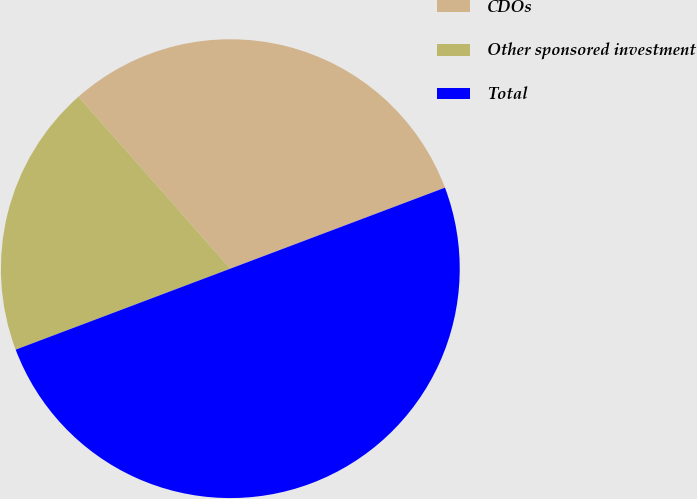Convert chart. <chart><loc_0><loc_0><loc_500><loc_500><pie_chart><fcel>CDOs<fcel>Other sponsored investment<fcel>Total<nl><fcel>30.77%<fcel>19.23%<fcel>50.0%<nl></chart> 